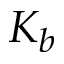<formula> <loc_0><loc_0><loc_500><loc_500>K _ { b }</formula> 